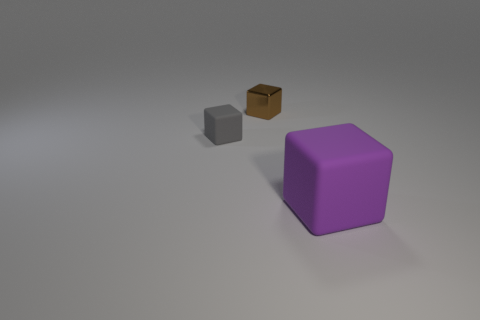Are there an equal number of tiny yellow balls and brown blocks?
Provide a short and direct response. No. Is there a big purple rubber thing of the same shape as the tiny gray rubber thing?
Give a very brief answer. Yes. Is the size of the rubber cube that is to the left of the large rubber object the same as the matte block in front of the small gray matte thing?
Give a very brief answer. No. Is the number of purple rubber objects that are behind the big rubber block less than the number of tiny rubber cubes that are behind the brown thing?
Your response must be concise. No. What color is the object on the left side of the brown shiny cube?
Offer a very short reply. Gray. Does the small matte block have the same color as the big rubber object?
Your answer should be compact. No. How many big purple blocks are left of the block on the right side of the thing behind the gray matte block?
Offer a very short reply. 0. The purple rubber cube has what size?
Provide a short and direct response. Large. There is a gray cube that is the same size as the brown shiny block; what material is it?
Ensure brevity in your answer.  Rubber. There is a tiny gray thing; how many tiny shiny objects are in front of it?
Offer a very short reply. 0. 